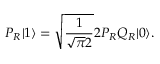Convert formula to latex. <formula><loc_0><loc_0><loc_500><loc_500>P _ { R } | 1 \rangle = \sqrt { \frac { 1 } { \sqrt { \pi } 2 } } 2 P _ { R } Q _ { R } | 0 \rangle .</formula> 